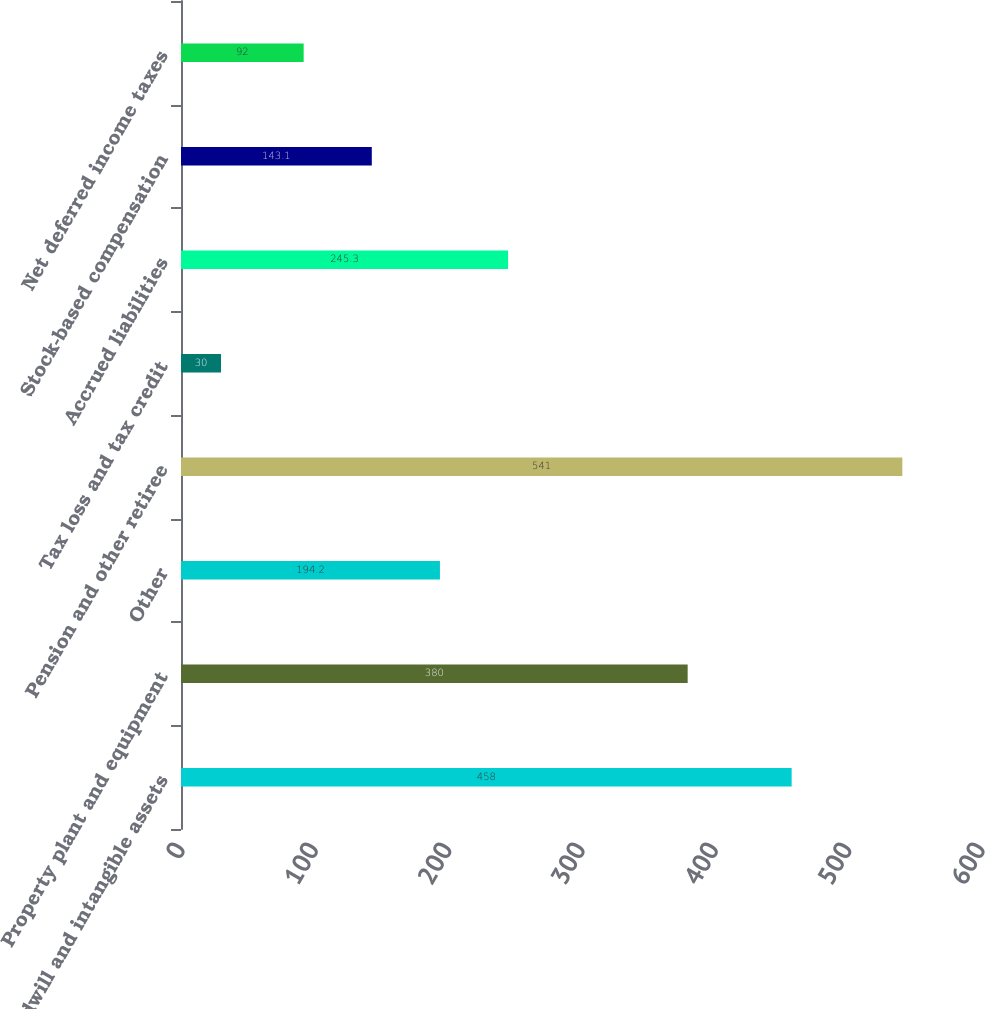Convert chart. <chart><loc_0><loc_0><loc_500><loc_500><bar_chart><fcel>Goodwill and intangible assets<fcel>Property plant and equipment<fcel>Other<fcel>Pension and other retiree<fcel>Tax loss and tax credit<fcel>Accrued liabilities<fcel>Stock-based compensation<fcel>Net deferred income taxes<nl><fcel>458<fcel>380<fcel>194.2<fcel>541<fcel>30<fcel>245.3<fcel>143.1<fcel>92<nl></chart> 